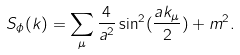Convert formula to latex. <formula><loc_0><loc_0><loc_500><loc_500>S _ { \phi } ( k ) = \sum _ { \mu } \frac { 4 } { a ^ { 2 } } \sin ^ { 2 } ( \frac { a k _ { \mu } } { 2 } ) + m ^ { 2 } .</formula> 